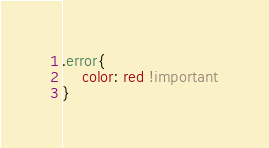<code> <loc_0><loc_0><loc_500><loc_500><_CSS_>.error{
	color: red !important
}</code> 